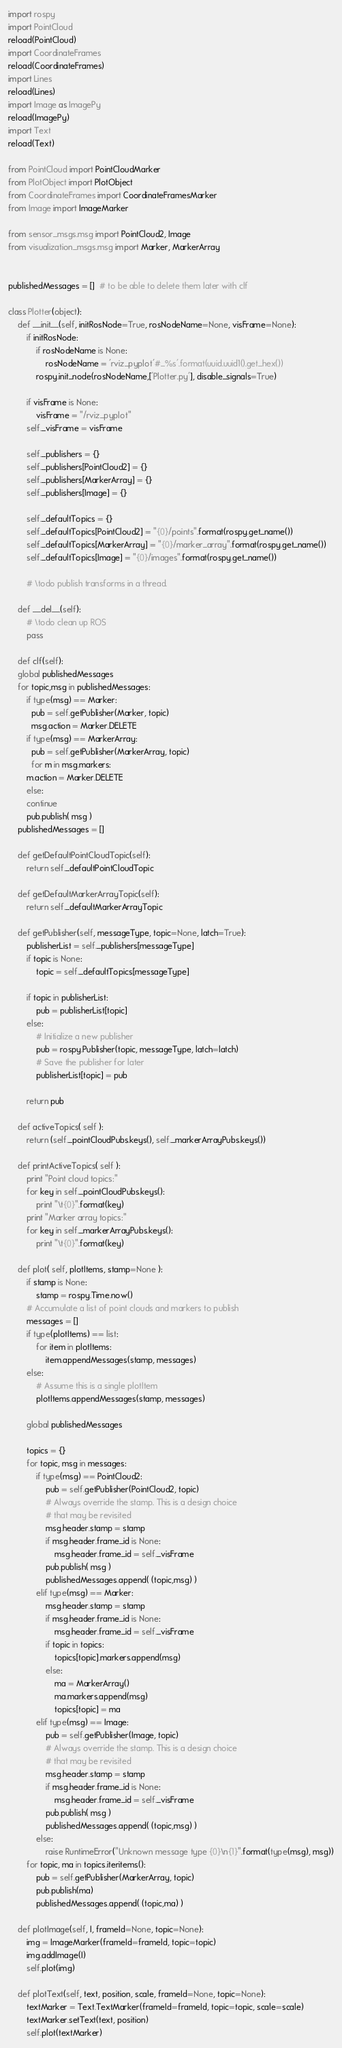Convert code to text. <code><loc_0><loc_0><loc_500><loc_500><_Python_>import rospy
import PointCloud
reload(PointCloud)
import CoordinateFrames
reload(CoordinateFrames)  
import Lines
reload(Lines)
import Image as ImagePy
reload(ImagePy)
import Text
reload(Text)

from PointCloud import PointCloudMarker
from PlotObject import PlotObject  
from CoordinateFrames import CoordinateFramesMarker
from Image import ImageMarker

from sensor_msgs.msg import PointCloud2, Image
from visualization_msgs.msg import Marker, MarkerArray


publishedMessages = []  # to be able to delete them later with clf

class Plotter(object):
    def __init__(self, initRosNode=True, rosNodeName=None, visFrame=None):
        if initRosNode:
            if rosNodeName is None:
                rosNodeName = 'rviz_pyplot'#_%s'.format(uuid.uuid1().get_hex())
            rospy.init_node(rosNodeName,['Plotter.py'], disable_signals=True)
        
        if visFrame is None:
            visFrame = "/rviz_pyplot"
        self._visFrame = visFrame

        self._publishers = {}
        self._publishers[PointCloud2] = {}
        self._publishers[MarkerArray] = {}
        self._publishers[Image] = {}

        self._defaultTopics = {}
        self._defaultTopics[PointCloud2] = "{0}/points".format(rospy.get_name())
        self._defaultTopics[MarkerArray] = "{0}/marker_array".format(rospy.get_name())
        self._defaultTopics[Image] = "{0}/images".format(rospy.get_name())

        # \todo publish transforms in a thread.

    def __del__(self):
        # \todo clean up ROS
        pass

    def clf(self):
	global publishedMessages
	for topic,msg in publishedMessages:
	    if type(msg) == Marker:
	      pub = self.getPublisher(Marker, topic)
	      msg.action = Marker.DELETE
	    if type(msg) == MarkerArray:
	      pub = self.getPublisher(MarkerArray, topic)
	      for m in msg.markers:
		m.action = Marker.DELETE
	    else:
		continue
	    pub.publish( msg )
	publishedMessages = []
    
    def getDefaultPointCloudTopic(self):
        return self._defaultPointCloudTopic

    def getDefaultMarkerArrayTopic(self):
        return self._defaultMarkerArrayTopic

    def getPublisher(self, messageType, topic=None, latch=True):
        publisherList = self._publishers[messageType]
        if topic is None:
            topic = self._defaultTopics[messageType]

        if topic in publisherList:
            pub = publisherList[topic]
        else:
            # Initialize a new publisher
            pub = rospy.Publisher(topic, messageType, latch=latch)
            # Save the publisher for later
            publisherList[topic] = pub

        return pub

    def activeTopics( self ):
        return (self._pointCloudPubs.keys(), self._markerArrayPubs.keys())
    
    def printActiveTopics( self ):
        print "Point cloud topics:"
        for key in self._pointCloudPubs.keys():
            print "\t{0}".format(key)
        print "Marker array topics:"
        for key in self._markerArrayPubs.keys():
            print "\t{0}".format(key)

    def plot( self, plotItems, stamp=None ):
        if stamp is None:
            stamp = rospy.Time.now()
        # Accumulate a list of point clouds and markers to publish
        messages = []
        if type(plotItems) == list:
            for item in plotItems:
                item.appendMessages(stamp, messages)
        else:
            # Assume this is a single plotItem
            plotItems.appendMessages(stamp, messages)

        global publishedMessages
	
        topics = {}        
        for topic, msg in messages:
            if type(msg) == PointCloud2:
                pub = self.getPublisher(PointCloud2, topic)
                # Always override the stamp. This is a design choice
                # that may be revisited
                msg.header.stamp = stamp
                if msg.header.frame_id is None:
                    msg.header.frame_id = self._visFrame
                pub.publish( msg )
                publishedMessages.append( (topic,msg) )
            elif type(msg) == Marker:
                msg.header.stamp = stamp
                if msg.header.frame_id is None:
                    msg.header.frame_id = self._visFrame
                if topic in topics:
                    topics[topic].markers.append(msg)
                else:
                    ma = MarkerArray()
                    ma.markers.append(msg)
                    topics[topic] = ma
            elif type(msg) == Image:
                pub = self.getPublisher(Image, topic)
                # Always override the stamp. This is a design choice
                # that may be revisited
                msg.header.stamp = stamp
                if msg.header.frame_id is None:
                    msg.header.frame_id = self._visFrame
                pub.publish( msg )
                publishedMessages.append( (topic,msg) )
            else:
                raise RuntimeError("Unknown message type {0}\n{1}".format(type(msg), msg))
        for topic, ma in topics.iteritems():
            pub = self.getPublisher(MarkerArray, topic)
            pub.publish(ma)
            publishedMessages.append( (topic,ma) )

    def plotImage(self, I, frameId=None, topic=None):
        img = ImageMarker(frameId=frameId, topic=topic)
        img.addImage(I)
        self.plot(img)

    def plotText(self, text, position, scale, frameId=None, topic=None):
        textMarker = Text.TextMarker(frameId=frameId, topic=topic, scale=scale)
        textMarker.setText(text, position)
        self.plot(textMarker)
</code> 